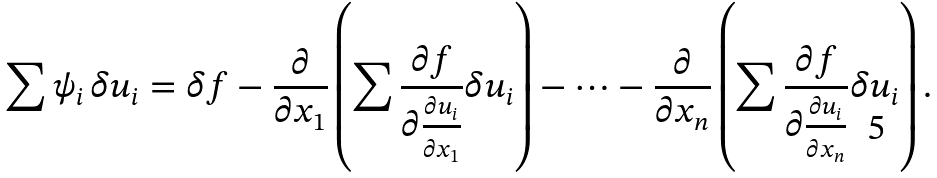Convert formula to latex. <formula><loc_0><loc_0><loc_500><loc_500>\sum \psi _ { i } \, \delta u _ { i } = \delta f - \frac { \partial } { \partial x _ { 1 } } \left ( \sum \frac { \partial f } { \partial \frac { \partial u _ { i } } { \partial x _ { 1 } } } \delta u _ { i } \right ) - \dots - \frac { \partial } { \partial x _ { n } } \left ( \sum \frac { \partial f } { \partial \frac { \partial u _ { i } } { \partial x _ { n } } } \delta u _ { i } \right ) .</formula> 